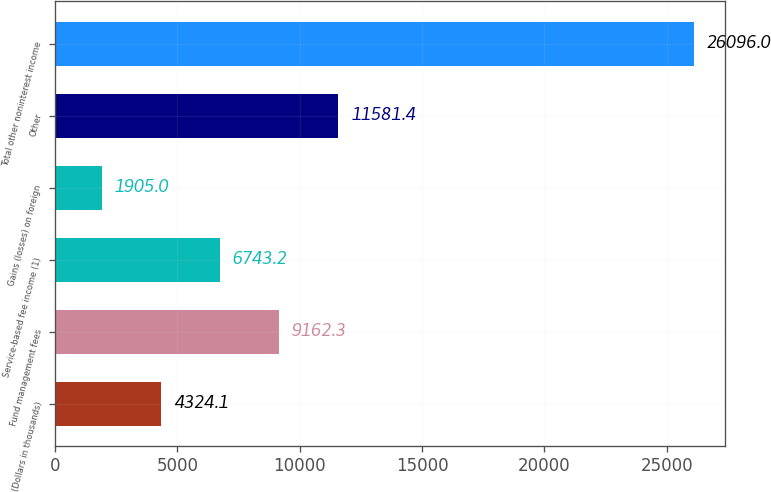<chart> <loc_0><loc_0><loc_500><loc_500><bar_chart><fcel>(Dollars in thousands)<fcel>Fund management fees<fcel>Service-based fee income (1)<fcel>Gains (losses) on foreign<fcel>Other<fcel>Total other noninterest income<nl><fcel>4324.1<fcel>9162.3<fcel>6743.2<fcel>1905<fcel>11581.4<fcel>26096<nl></chart> 